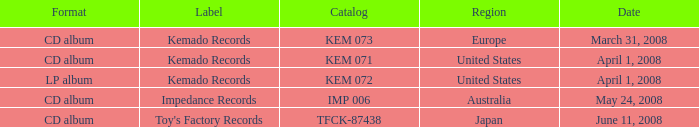Which Region has a Catalog of kem 072? United States. 